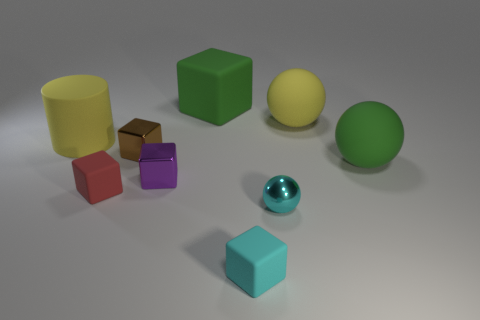Do the green thing that is behind the brown cube and the big green matte sphere have the same size?
Give a very brief answer. Yes. The other rubber sphere that is the same size as the yellow sphere is what color?
Give a very brief answer. Green. Are there any big rubber cylinders to the right of the big green object behind the yellow thing to the right of the red block?
Provide a succinct answer. No. What is the material of the tiny object that is on the right side of the cyan rubber thing?
Your answer should be very brief. Metal. Do the small red thing and the big green matte thing in front of the brown thing have the same shape?
Keep it short and to the point. No. Are there the same number of big rubber balls to the left of the cyan metal sphere and big objects that are behind the big rubber cylinder?
Your response must be concise. No. What number of other things are the same material as the small ball?
Your answer should be compact. 2. What number of metallic objects are big green things or yellow objects?
Give a very brief answer. 0. Does the metal thing in front of the small red cube have the same shape as the small brown shiny object?
Give a very brief answer. No. Are there more large green things that are in front of the tiny brown shiny object than green things?
Make the answer very short. No. 